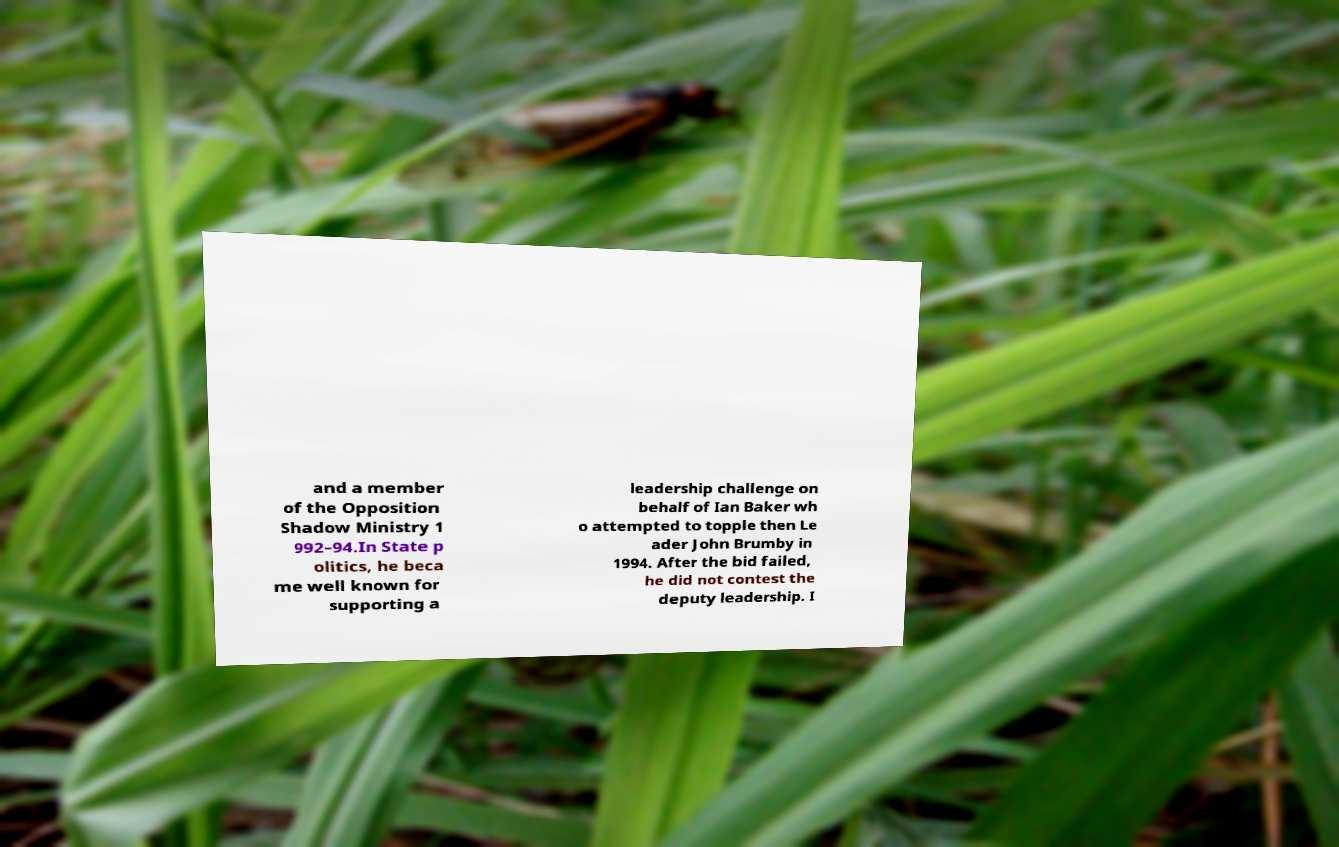Please identify and transcribe the text found in this image. and a member of the Opposition Shadow Ministry 1 992–94.In State p olitics, he beca me well known for supporting a leadership challenge on behalf of Ian Baker wh o attempted to topple then Le ader John Brumby in 1994. After the bid failed, he did not contest the deputy leadership. I 